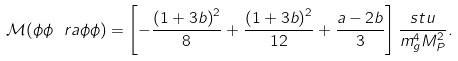<formula> <loc_0><loc_0><loc_500><loc_500>\mathcal { M } ( \phi \phi \ r a \phi \phi ) = \left [ - \frac { \left ( 1 + 3 b \right ) ^ { 2 } } { 8 } + \frac { \left ( 1 + 3 b \right ) ^ { 2 } } { 1 2 } + \frac { a - 2 b } { 3 } \right ] \frac { s t u } { m _ { g } ^ { 4 } M _ { P } ^ { 2 } } .</formula> 